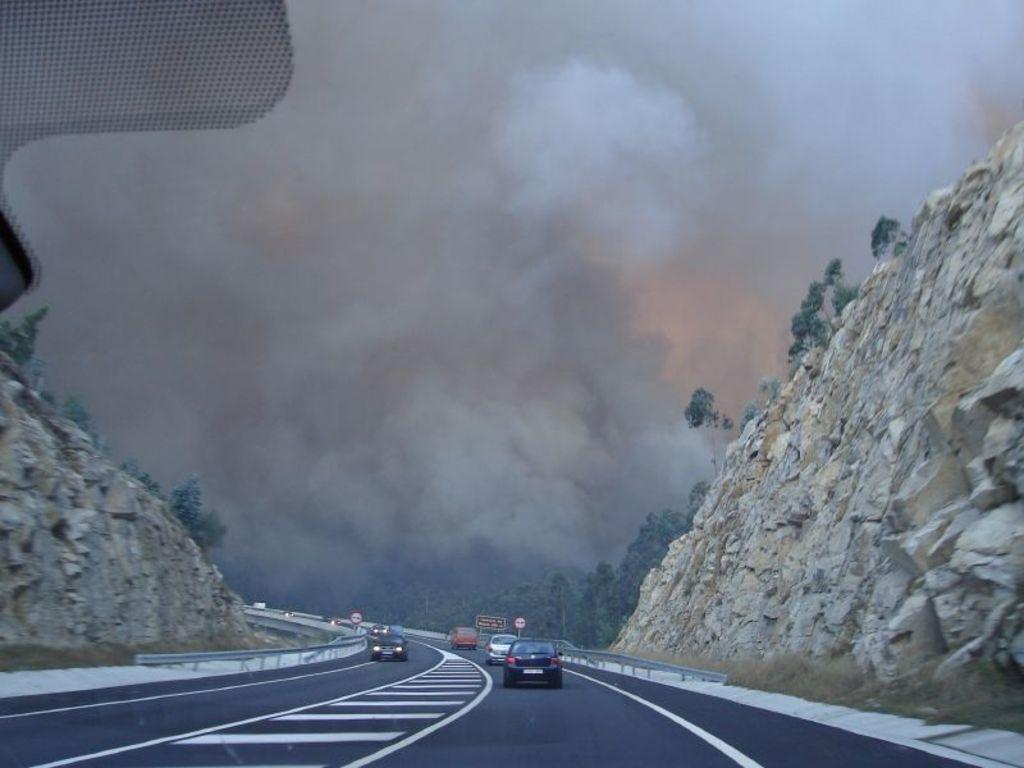In one or two sentences, can you explain what this image depicts? In the image we can see there are cars parked on the road and there rock hills on both the sides. Behind there are lot of trees and there is clear sky. 